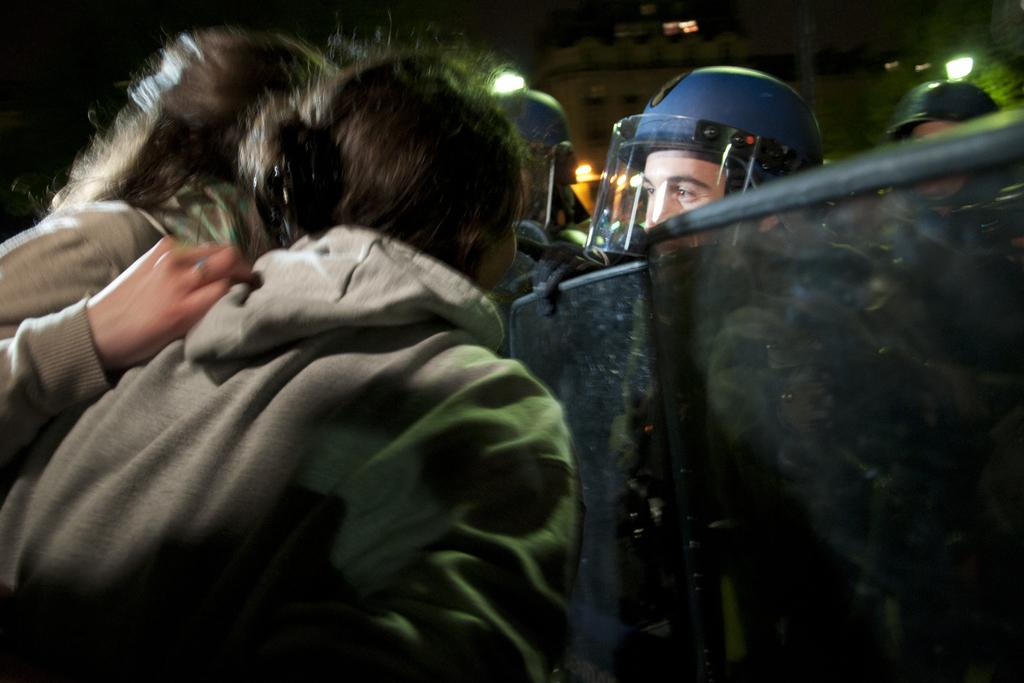What can be observed about the people in the image? There are people standing in the image, and some of them are wearing helmets. What are the people holding in their hands? Some of the people are holding barriers in their hands. What can be seen in the background of the image? There are buildings and electric lights in the background of the image. What is the rate at which the detail in the image is changing? The image is a still photograph, so there is no rate at which the detail is changing. 